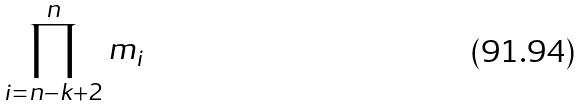Convert formula to latex. <formula><loc_0><loc_0><loc_500><loc_500>\prod _ { i = n - k + 2 } ^ { n } m _ { i }</formula> 